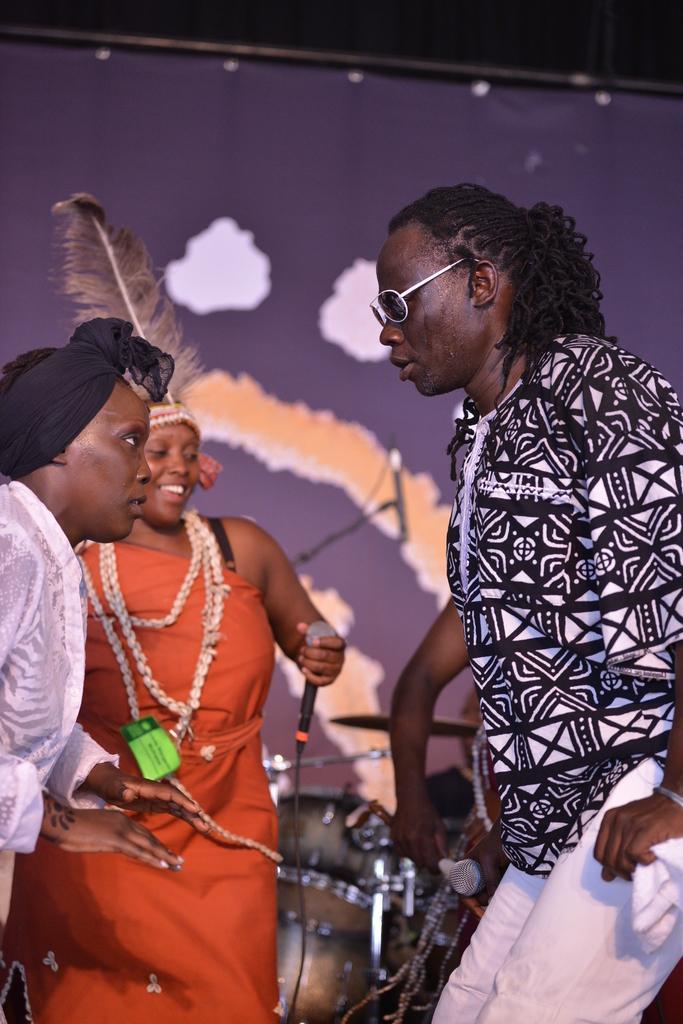In one or two sentences, can you explain what this image depicts? In this image there is a man and in front of the man there are two women standing one of the woman is holding a mic in her hand, behind her there are some musical instruments. 